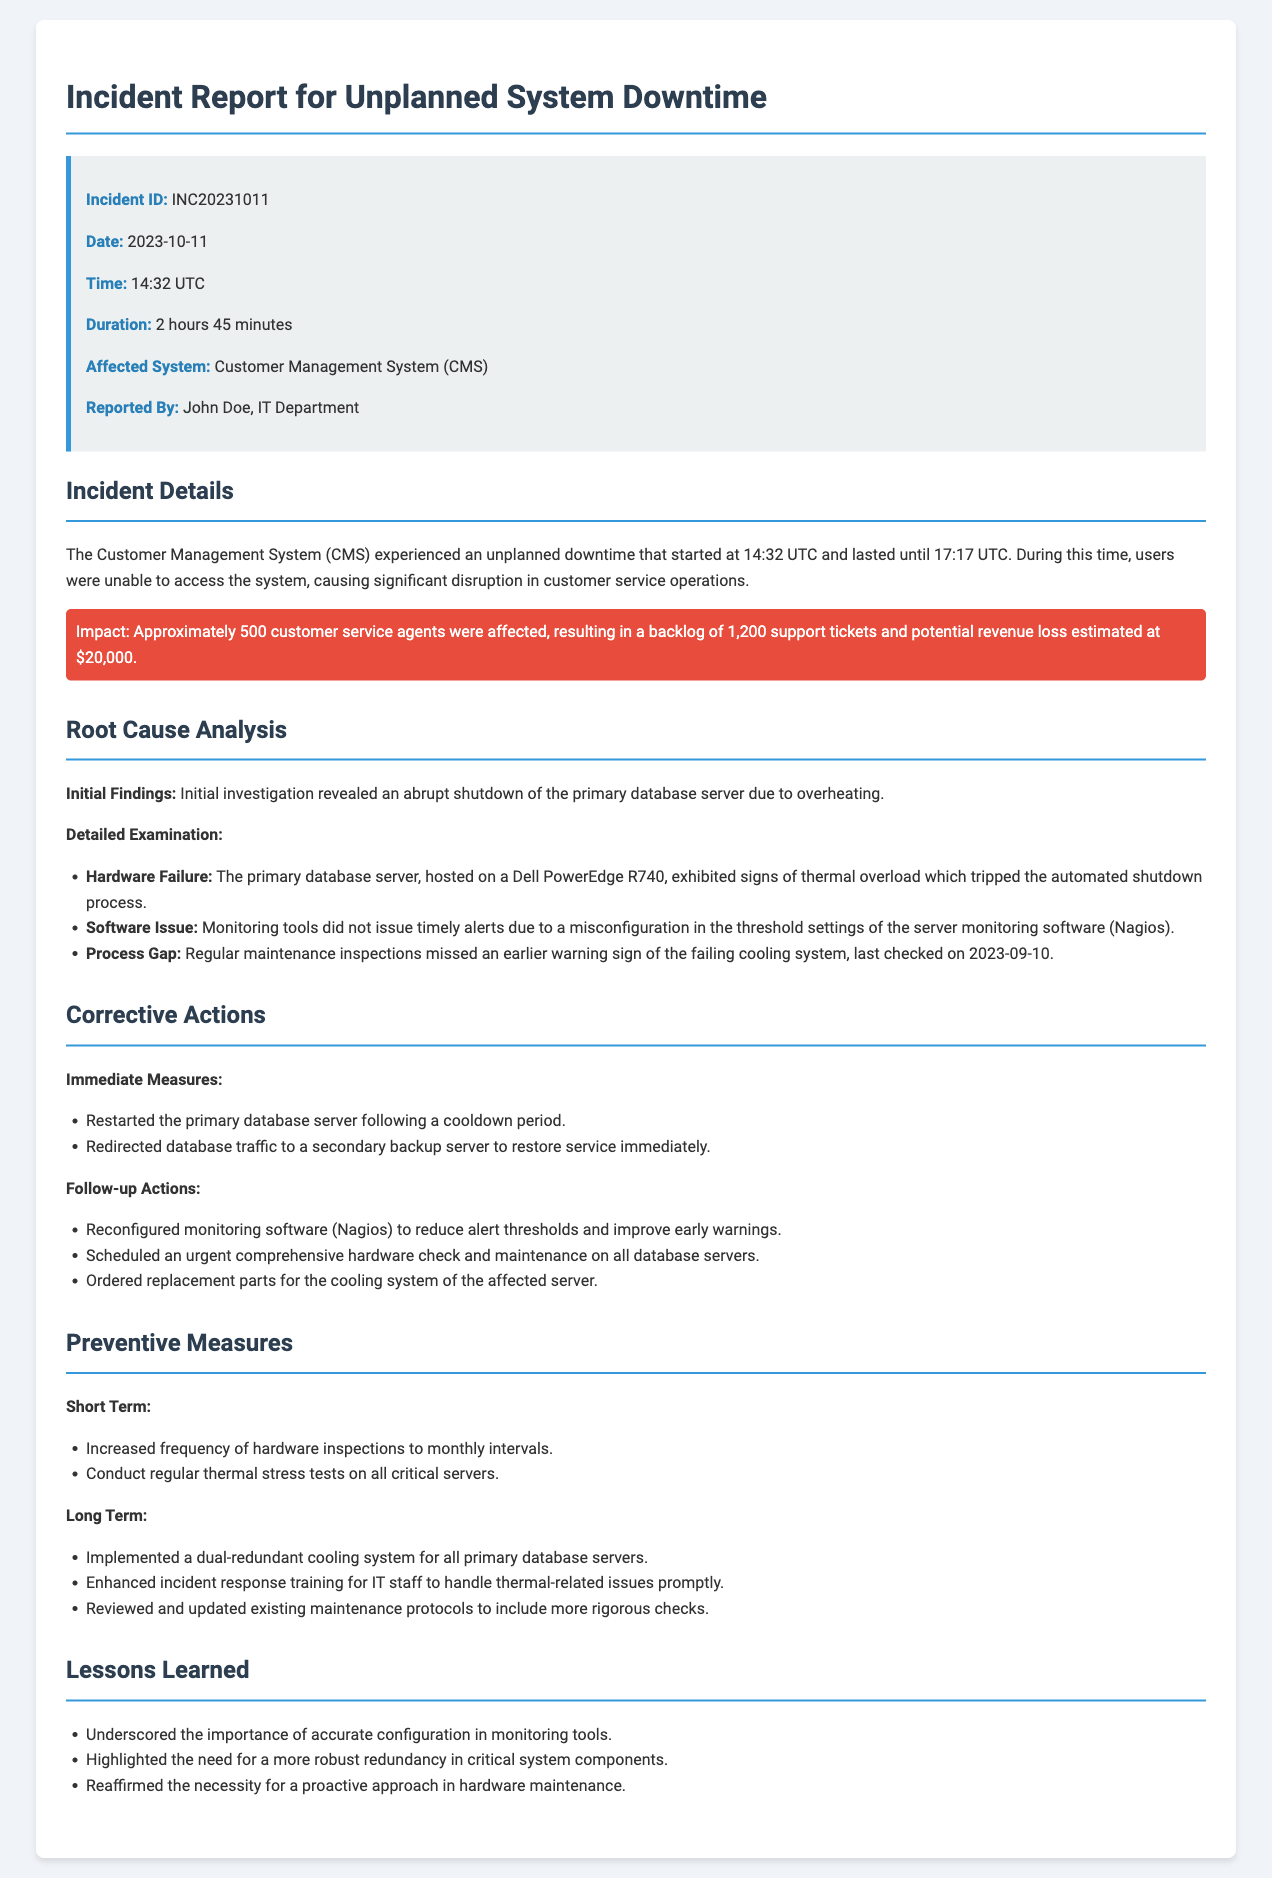What is the Incident ID? The Incident ID is explicitly stated in the document under the incident summary section.
Answer: INC20231011 When did the incident occur? The document provides the date of the incident in the incident summary section.
Answer: 2023-10-11 What was the duration of the downtime? The duration of the downtime is mentioned in the incident summary section and calculated from the time span provided.
Answer: 2 hours 45 minutes Who reported the incident? The name of the individual who reported the incident is provided in the incident summary.
Answer: John Doe What was the estimated potential revenue loss? The document states the estimated potential revenue loss in the incident details section.
Answer: $20,000 What was the root cause of the downtime? The root cause analysis section summarizes the main issue leading to the incident.
Answer: Overheating What corrective action was taken immediately after the incident? One of the first actions taken to resolve the incident is detailed in the corrective actions section.
Answer: Restarted the primary database server What short-term preventive measure was mentioned? The document lists specific short-term preventive measures in the preventive measures section.
Answer: Increased frequency of hardware inspections What lesson was learned regarding monitoring tools? Lessons learned section highlights the importance of accurate configurations related to monitoring.
Answer: Accurate configuration in monitoring tools What long-term preventive measure has been implemented? One of the long-term preventive measures to prevent future occurrences is specified in the preventive measures section.
Answer: Dual-redundant cooling system 